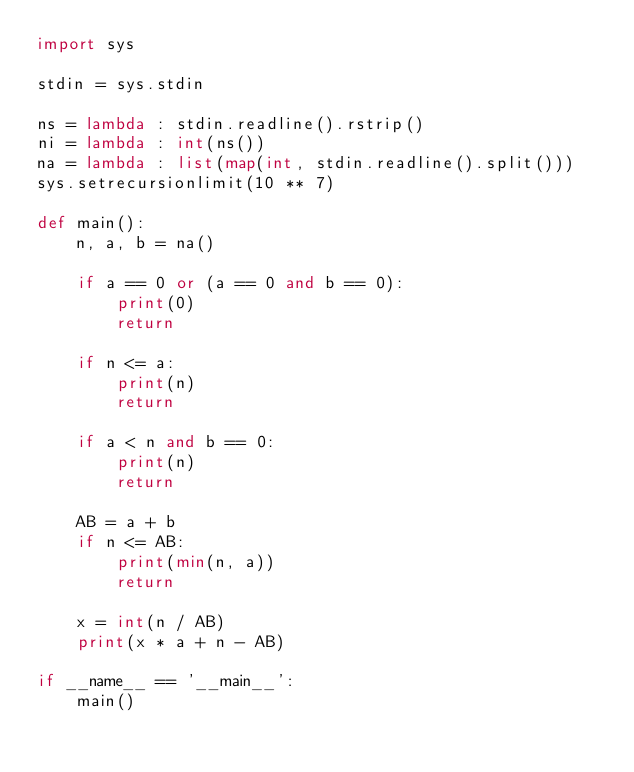Convert code to text. <code><loc_0><loc_0><loc_500><loc_500><_Python_>import sys

stdin = sys.stdin

ns = lambda : stdin.readline().rstrip()
ni = lambda : int(ns())
na = lambda : list(map(int, stdin.readline().split()))
sys.setrecursionlimit(10 ** 7)

def main():
    n, a, b = na()
    
    if a == 0 or (a == 0 and b == 0):
        print(0)
        return

    if n <= a:
        print(n)
        return
      
    if a < n and b == 0:
        print(n)
        return

    AB = a + b
    if n <= AB:
        print(min(n, a))
        return 
    
    x = int(n / AB)
    print(x * a + n - AB)

if __name__ == '__main__':
    main()</code> 